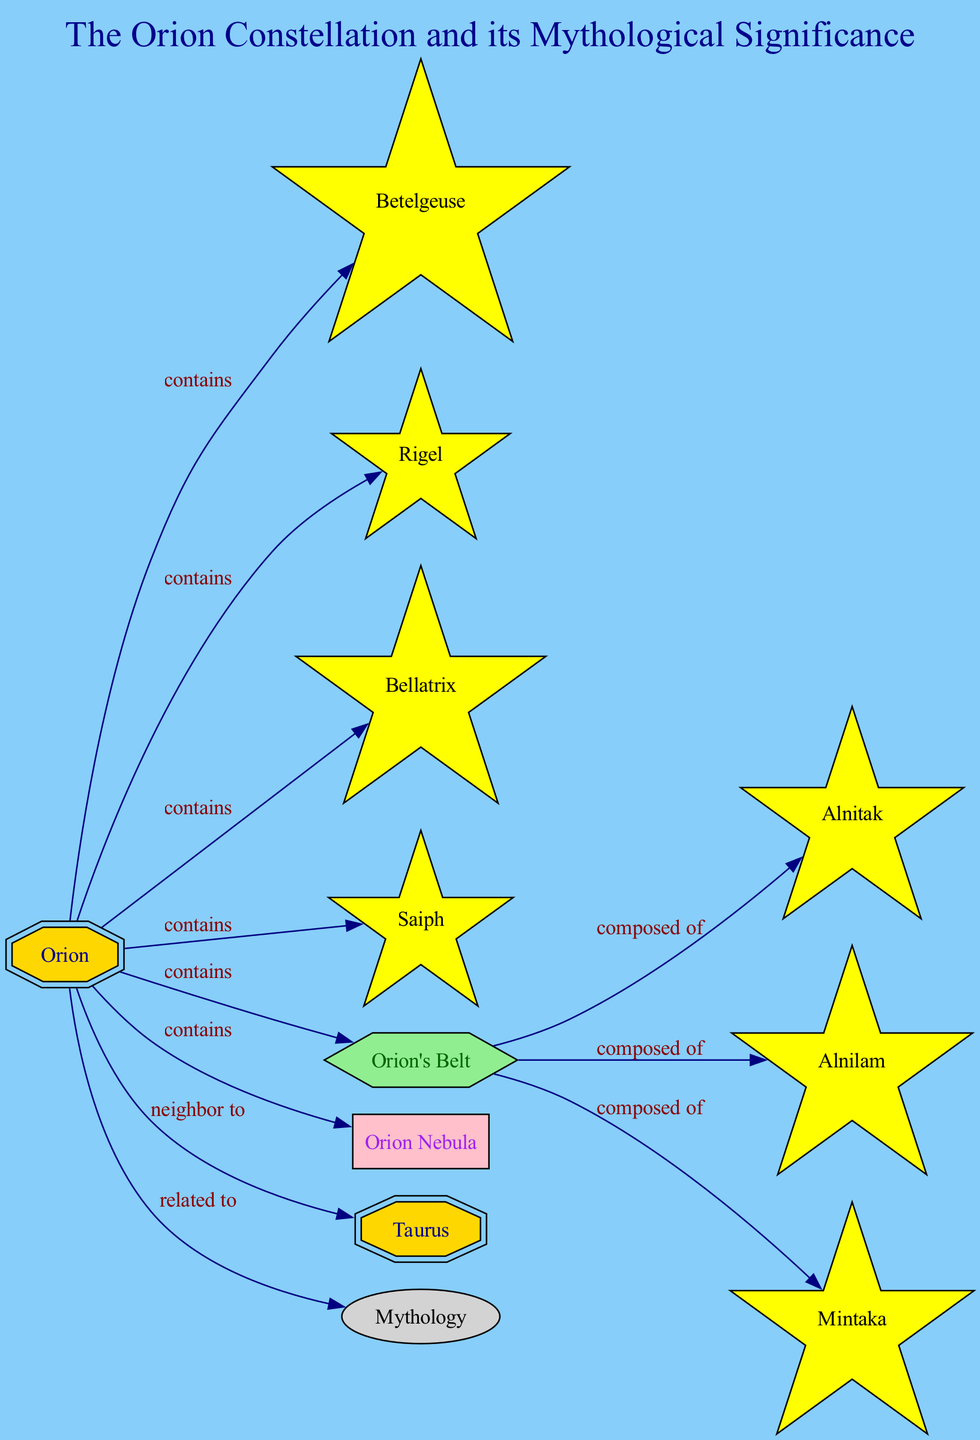How many stars are in the Orion constellation? The Orion constellation contains four main stars: Betelgeuse, Rigel, Bellatrix, and Saiph. Counting these gives us a total of four stars.
Answer: 4 What star represents Orion's left shoulder? The diagram indicates that Bellatrix represents Orion's left shoulder. This is specifically labeled in the diagram.
Answer: Bellatrix Which star is the easternmost in Orion's Belt? The diagram clearly labels Alnitak as the easternmost star of Orion's Belt.
Answer: Alnitak What is the relationship between Orion and Taurus? According to the diagram, Orion is shown to be a neighbor to Taurus, which defines their spatial relationship.
Answer: neighbor to How many stars compose Orion's Belt? The diagram specifies that Orion's Belt is composed of three stars: Alnitak, Alnilam, and Mintaka. Thus, the count is three.
Answer: 3 Which prominent nebula is located below Orion's Belt? The diagram directly indicates the Orion Nebula as being located below Orion's Belt. This information is explicitly presented.
Answer: Orion Nebula What mythological figure is Orion associated with? The diagram notes that Orion is significantly related to mythology, specifically, as a great hunter in Greek mythology.
Answer: hunter What type of star is Betelgeuse? It is clearly labeled in the diagram that Betelgeuse is a red supergiant star, which identifies its classification.
Answer: red supergiant What color is Rigel, and what does it represent in Orion? The diagram describes Rigel as a blue supergiant star forming Orion's foot, specifying both its color and position.
Answer: blue supergiant 